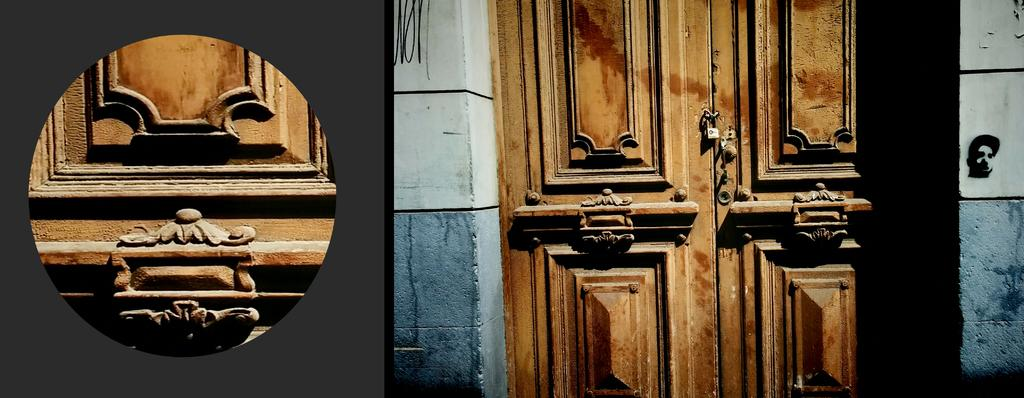What type of image is being described? The image is a collage of pictures. Can you identify any specific objects or elements in the collage? Yes, there is a door in the image. Where is the door located within the collage? The door is on a wall. Are there any unique features on the door? Yes, there is a wooden carving on the door in the first picture of the collage. What scientific division is represented by the door in the image? The image does not depict any scientific divisions; it is a collages pictures, including a door with a wooden carving. 